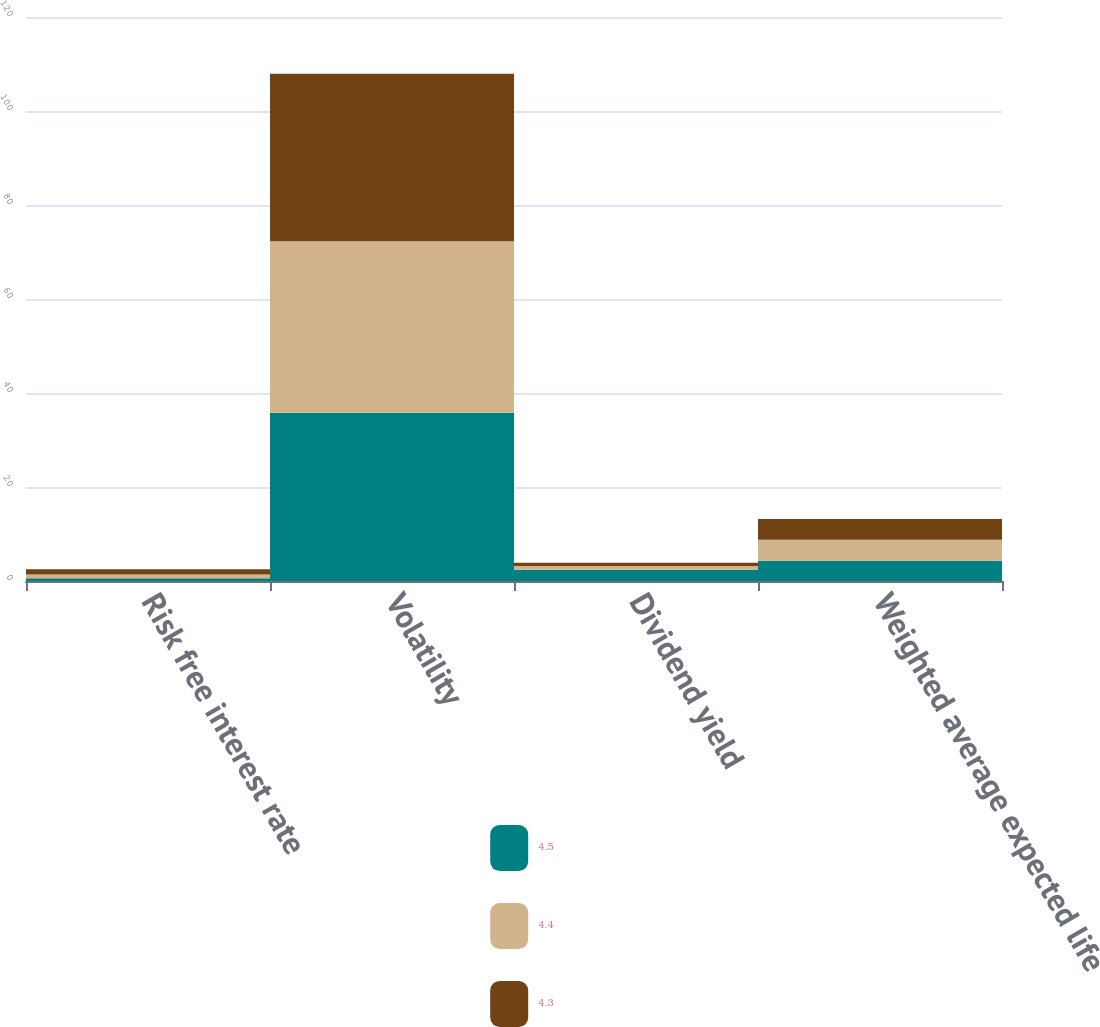Convert chart. <chart><loc_0><loc_0><loc_500><loc_500><stacked_bar_chart><ecel><fcel>Risk free interest rate<fcel>Volatility<fcel>Dividend yield<fcel>Weighted average expected life<nl><fcel>4.5<fcel>0.6<fcel>35.8<fcel>2.4<fcel>4.3<nl><fcel>4.4<fcel>0.8<fcel>36.5<fcel>0.8<fcel>4.5<nl><fcel>4.3<fcel>1.1<fcel>35.6<fcel>0.7<fcel>4.4<nl></chart> 